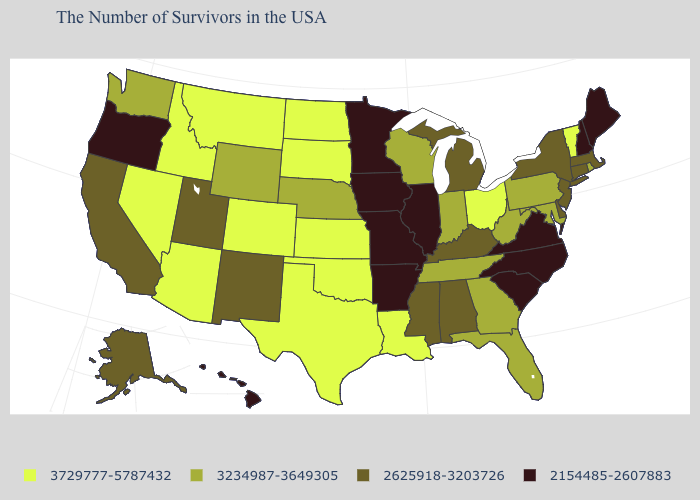Among the states that border Arkansas , which have the highest value?
Answer briefly. Louisiana, Oklahoma, Texas. Name the states that have a value in the range 2625918-3203726?
Concise answer only. Massachusetts, Connecticut, New York, New Jersey, Delaware, Michigan, Kentucky, Alabama, Mississippi, New Mexico, Utah, California, Alaska. What is the value of Pennsylvania?
Write a very short answer. 3234987-3649305. Among the states that border Kentucky , which have the highest value?
Quick response, please. Ohio. What is the value of Maryland?
Concise answer only. 3234987-3649305. What is the value of Mississippi?
Quick response, please. 2625918-3203726. Among the states that border New Hampshire , which have the lowest value?
Quick response, please. Maine. Does Massachusetts have the lowest value in the Northeast?
Quick response, please. No. Does Delaware have a lower value than Arizona?
Short answer required. Yes. Name the states that have a value in the range 3729777-5787432?
Write a very short answer. Vermont, Ohio, Louisiana, Kansas, Oklahoma, Texas, South Dakota, North Dakota, Colorado, Montana, Arizona, Idaho, Nevada. Among the states that border North Carolina , which have the highest value?
Short answer required. Georgia, Tennessee. What is the lowest value in states that border Arkansas?
Quick response, please. 2154485-2607883. Among the states that border New Jersey , which have the lowest value?
Give a very brief answer. New York, Delaware. What is the highest value in states that border Tennessee?
Quick response, please. 3234987-3649305. What is the value of North Carolina?
Be succinct. 2154485-2607883. 